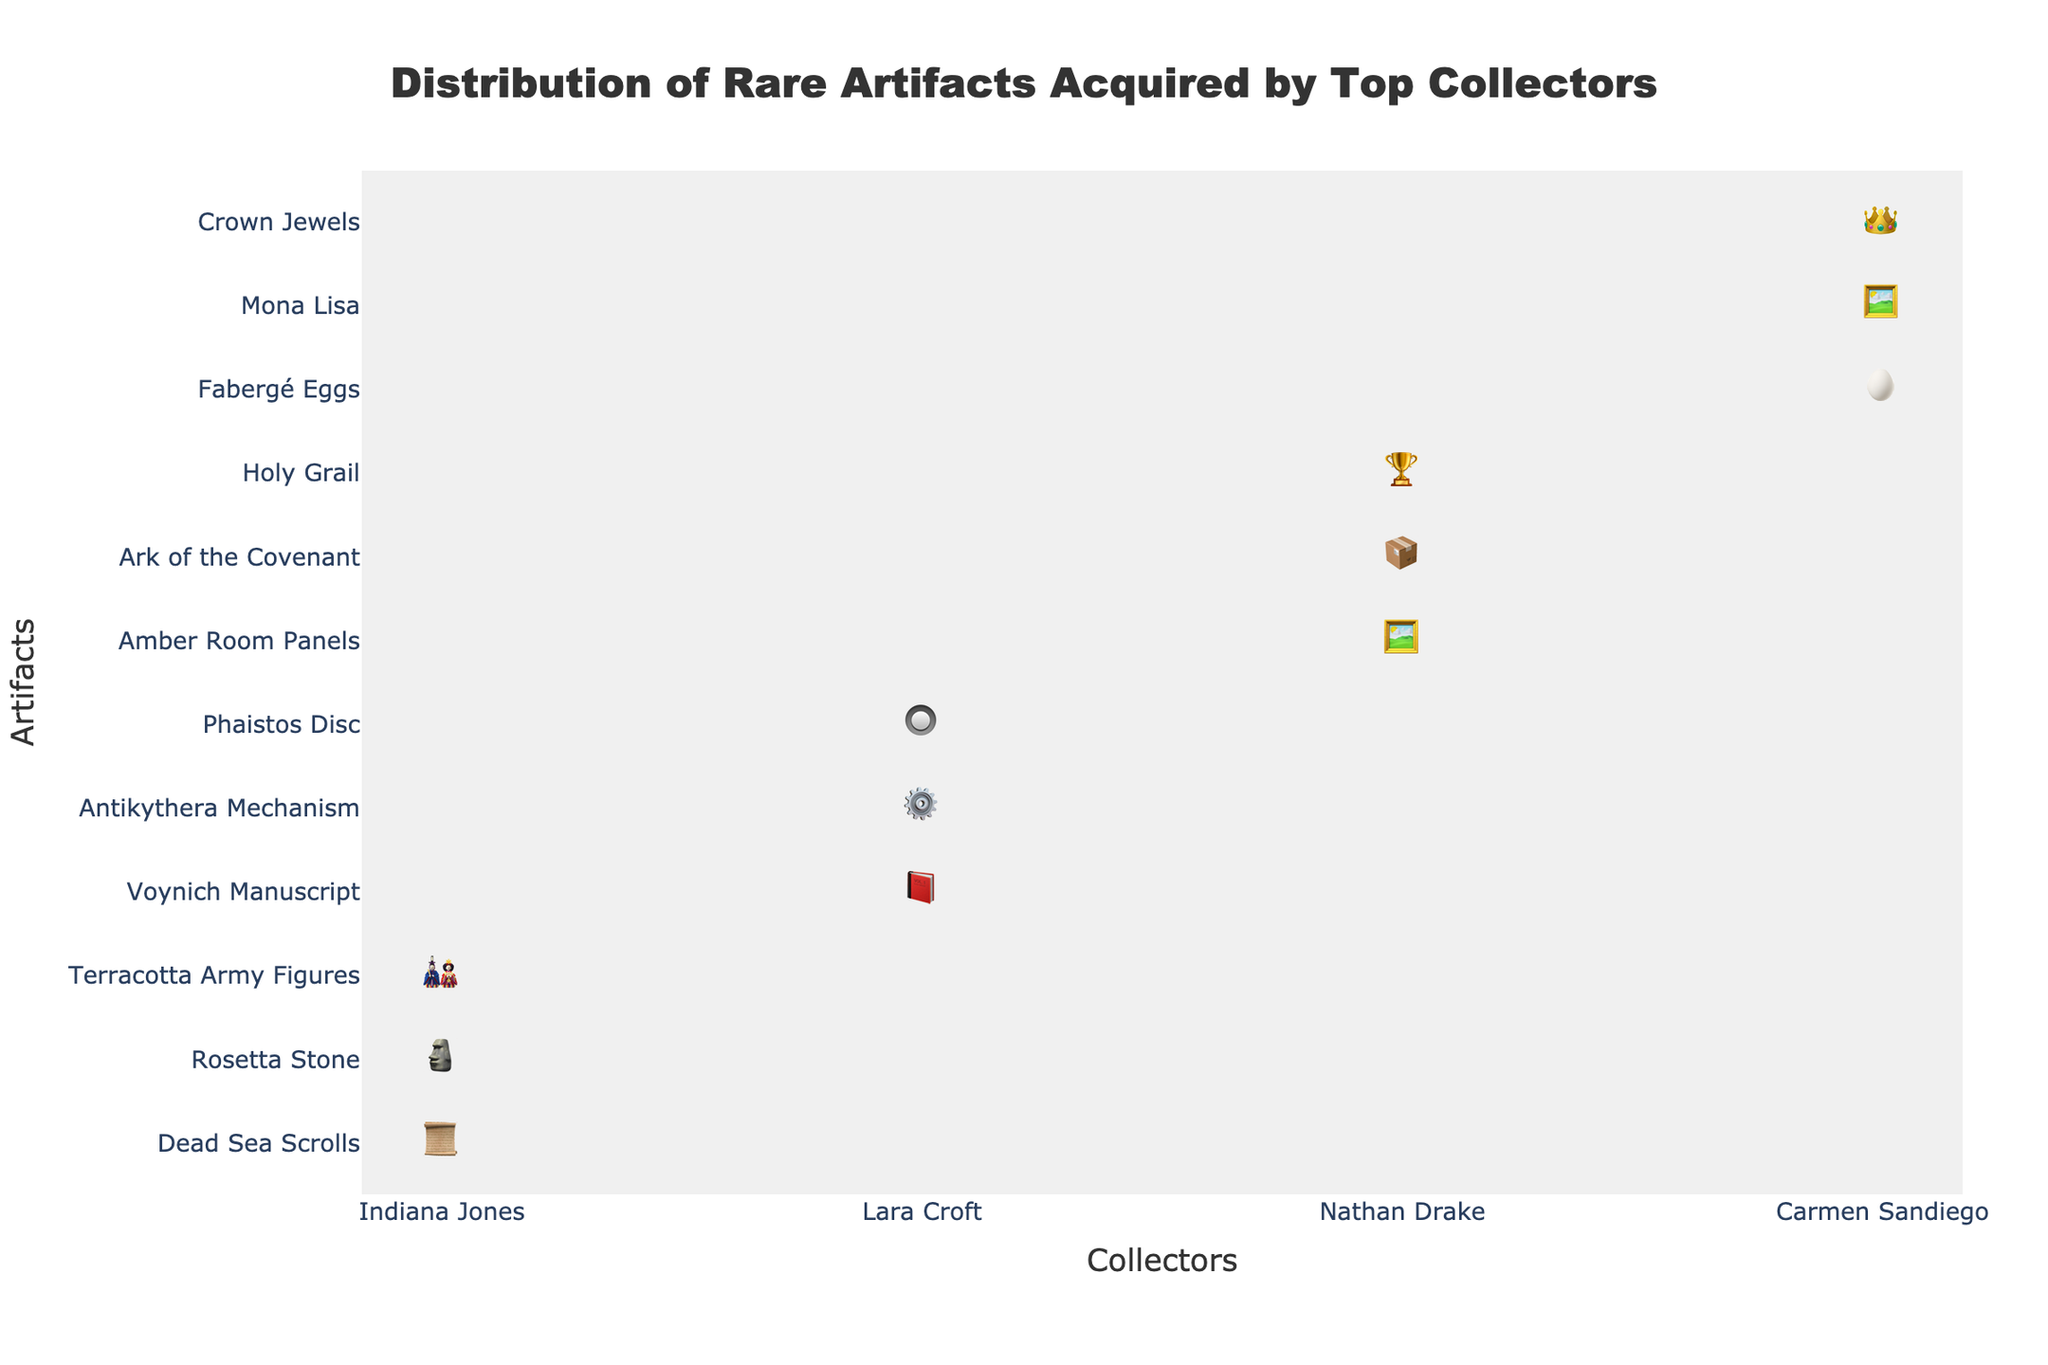What is the title of the figure? The title is typically located at the top center of the figure inside a text box. Here it reads "Distribution of Rare Artifacts Acquired by Top Collectors".
Answer: Distribution of Rare Artifacts Acquired by Top Collectors Which collector has acquired the highest number of artifacts? By examining the icons in each collector's column, Indiana Jones appears to have the most artifacts.
Answer: Indiana Jones How many artifacts has Nathan Drake acquired in total? By adding up the counts for Nathan Drake: Amber Room Panels (4) + Ark of the Covenant (1) + Holy Grail (1) = 6 artifacts.
Answer: 6 Which artifact has the highest count overall? By summing the counts of each type of artifact, the Terracotta Army Figures, acquired by Indiana Jones, have the highest count of 12.
Answer: Terracotta Army Figures How does Carmen Sandiego's acquisition compare to Lara Croft's for the artifact count? Carmen Sandiego (7 Fabergé Eggs + 1 Mona Lisa + 3 Crown Jewels = 11) has more artifacts than Lara Croft (1 Voynich Manuscript + 1 Antikythera Mechanism + 1 Phaistos Disc = 3).
Answer: Carmen Sandiego has more artifacts than Lara Croft Which collector has acquired the unique artifact "Rosetta Stone"? By scanning the icon under Rosetta Stone, it is only present under Indiana Jones' column.
Answer: Indiana Jones What is the most diverse collection of artifacts, and which collector owns it? Diversity can be gauged by counting the unique types of artifacts each collector has. Indiana Jones has 3 different types, Lara Croft has 3 different types, Nathan Drake has 3 different types, and Carmen Sandiego has 3 different types. All of them have equally diverse collections.
Answer: All collectors have equally diverse collections Who collected the Dead Sea Scrolls and how many were collected? The column with the icons for Dead Sea Scrolls belongs to Indiana Jones, and there are 8 icons.
Answer: Indiana Jones, 8 Which artifact has been acquired by more than one collector? According to the distribution, only the "🖼️" icon, used for both Amber Room Panels and Mona Lisa, suggest similar categories but different artifacts. No specific artifact among the rare ones exists in multiple collections.
Answer: None Who collected the least number of artifacts, and how many did they collect? By inspecting each collector, Lara Croft has the least number of artifacts, with a total of 3.
Answer: Lara Croft, 3 